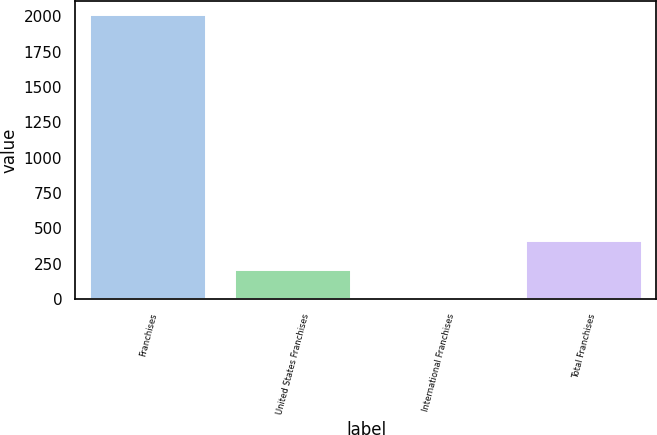Convert chart. <chart><loc_0><loc_0><loc_500><loc_500><bar_chart><fcel>Franchises<fcel>United States Franchises<fcel>International Franchises<fcel>Total Franchises<nl><fcel>2007<fcel>207<fcel>7<fcel>407<nl></chart> 